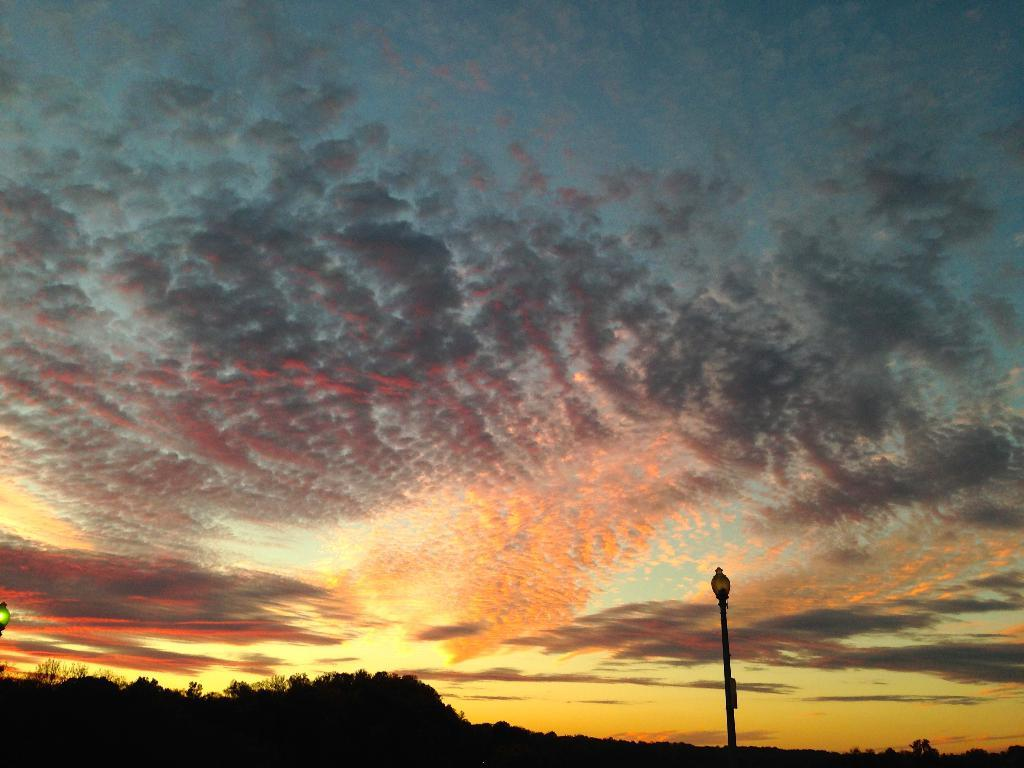What time of day is depicted in the image? The image is taken during sunset. What can be seen on the right side of the image? There is a pole on the right side of the image. What type of vegetation is on the left side of the image? There are trees on the left side of the image. What is visible at the top of the image? The sky is visible at the top of the image. How many women are present in the image? There are no women present in the image. What type of order is being followed by the ship in the image? There is no ship present in the image. 